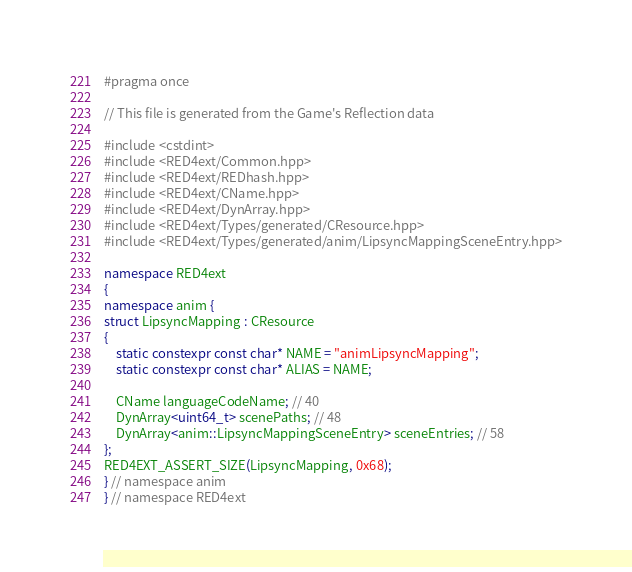Convert code to text. <code><loc_0><loc_0><loc_500><loc_500><_C++_>#pragma once

// This file is generated from the Game's Reflection data

#include <cstdint>
#include <RED4ext/Common.hpp>
#include <RED4ext/REDhash.hpp>
#include <RED4ext/CName.hpp>
#include <RED4ext/DynArray.hpp>
#include <RED4ext/Types/generated/CResource.hpp>
#include <RED4ext/Types/generated/anim/LipsyncMappingSceneEntry.hpp>

namespace RED4ext
{
namespace anim { 
struct LipsyncMapping : CResource
{
    static constexpr const char* NAME = "animLipsyncMapping";
    static constexpr const char* ALIAS = NAME;

    CName languageCodeName; // 40
    DynArray<uint64_t> scenePaths; // 48
    DynArray<anim::LipsyncMappingSceneEntry> sceneEntries; // 58
};
RED4EXT_ASSERT_SIZE(LipsyncMapping, 0x68);
} // namespace anim
} // namespace RED4ext
</code> 